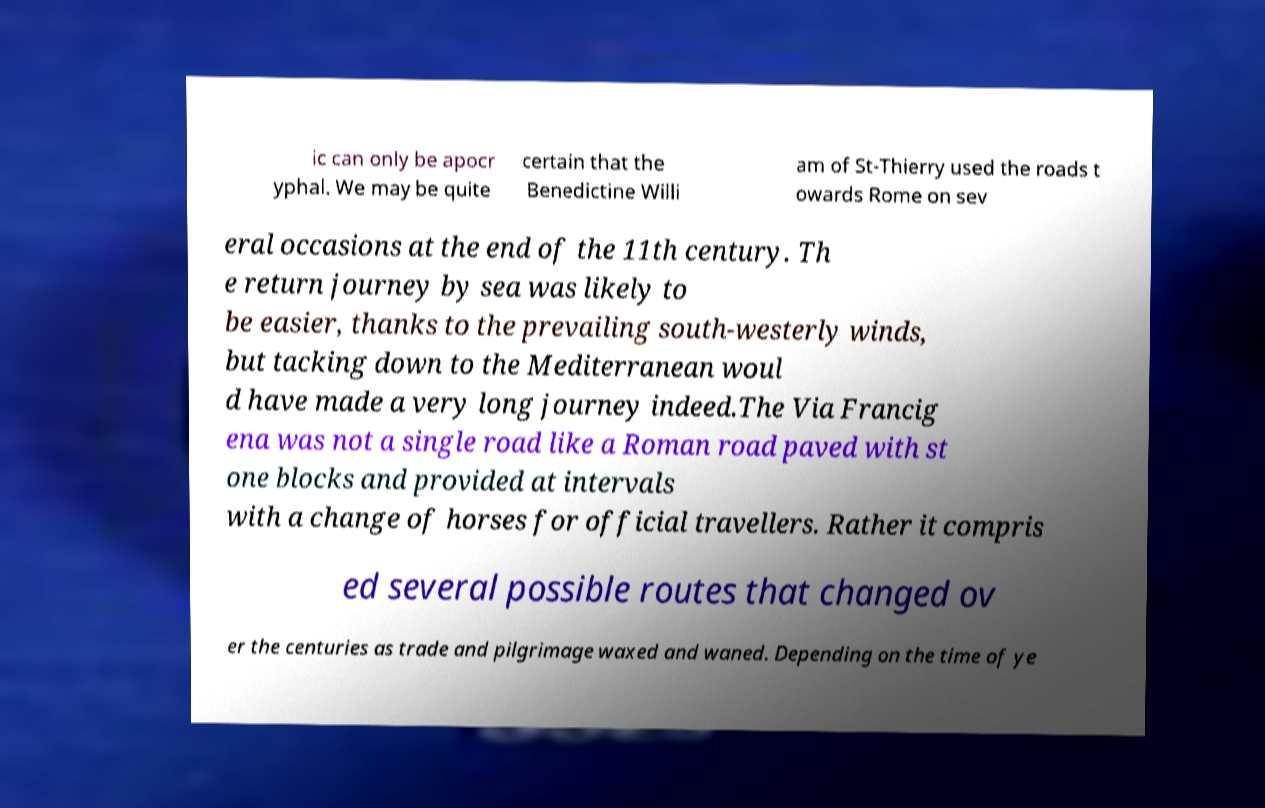What messages or text are displayed in this image? I need them in a readable, typed format. ic can only be apocr yphal. We may be quite certain that the Benedictine Willi am of St-Thierry used the roads t owards Rome on sev eral occasions at the end of the 11th century. Th e return journey by sea was likely to be easier, thanks to the prevailing south-westerly winds, but tacking down to the Mediterranean woul d have made a very long journey indeed.The Via Francig ena was not a single road like a Roman road paved with st one blocks and provided at intervals with a change of horses for official travellers. Rather it compris ed several possible routes that changed ov er the centuries as trade and pilgrimage waxed and waned. Depending on the time of ye 